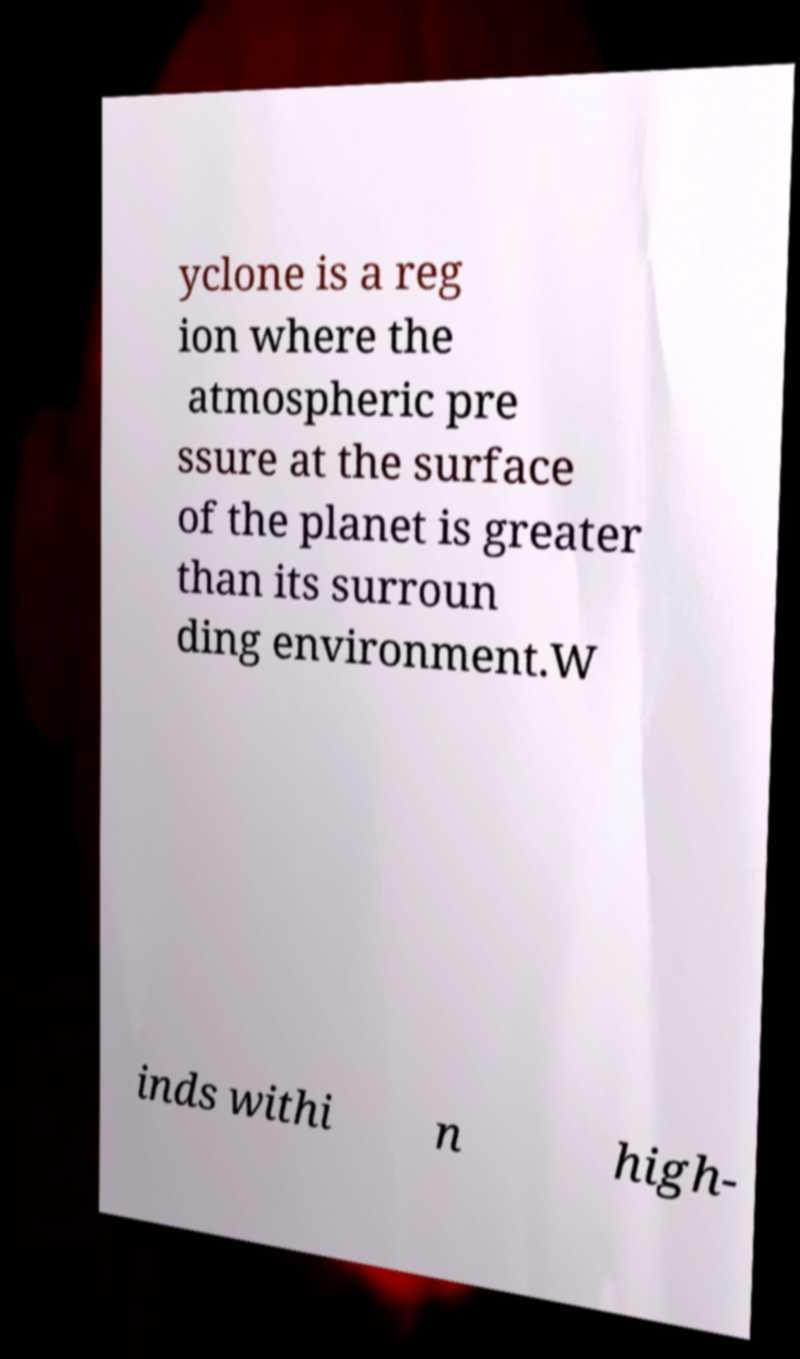Please read and relay the text visible in this image. What does it say? yclone is a reg ion where the atmospheric pre ssure at the surface of the planet is greater than its surroun ding environment.W inds withi n high- 